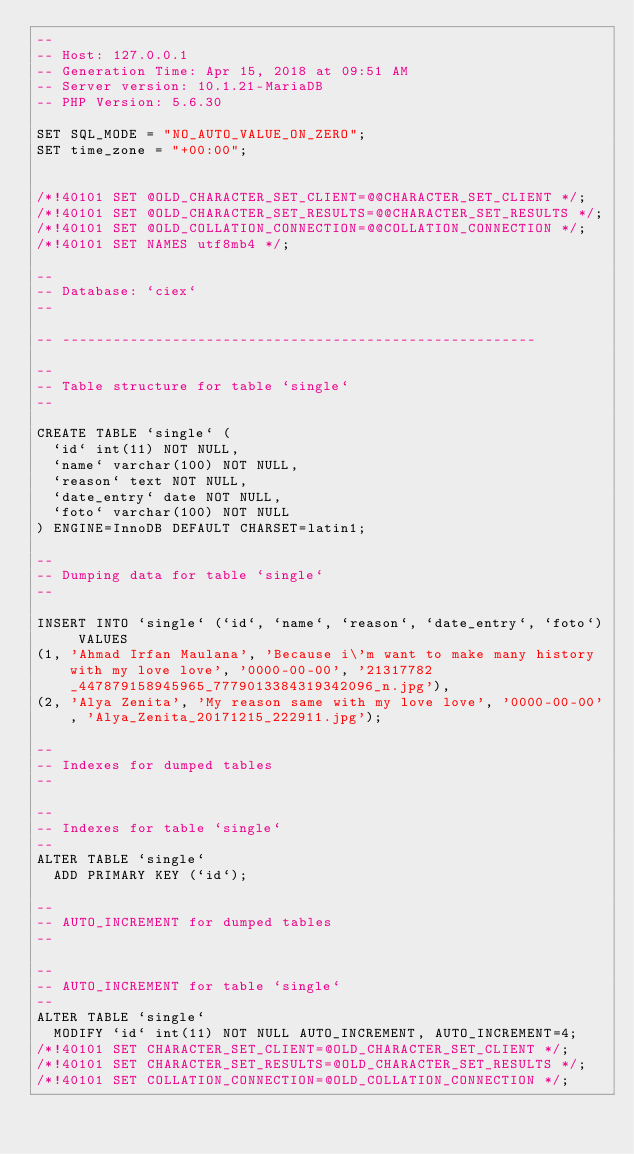Convert code to text. <code><loc_0><loc_0><loc_500><loc_500><_SQL_>--
-- Host: 127.0.0.1
-- Generation Time: Apr 15, 2018 at 09:51 AM
-- Server version: 10.1.21-MariaDB
-- PHP Version: 5.6.30

SET SQL_MODE = "NO_AUTO_VALUE_ON_ZERO";
SET time_zone = "+00:00";


/*!40101 SET @OLD_CHARACTER_SET_CLIENT=@@CHARACTER_SET_CLIENT */;
/*!40101 SET @OLD_CHARACTER_SET_RESULTS=@@CHARACTER_SET_RESULTS */;
/*!40101 SET @OLD_COLLATION_CONNECTION=@@COLLATION_CONNECTION */;
/*!40101 SET NAMES utf8mb4 */;

--
-- Database: `ciex`
--

-- --------------------------------------------------------

--
-- Table structure for table `single`
--

CREATE TABLE `single` (
  `id` int(11) NOT NULL,
  `name` varchar(100) NOT NULL,
  `reason` text NOT NULL,
  `date_entry` date NOT NULL,
  `foto` varchar(100) NOT NULL
) ENGINE=InnoDB DEFAULT CHARSET=latin1;

--
-- Dumping data for table `single`
--

INSERT INTO `single` (`id`, `name`, `reason`, `date_entry`, `foto`) VALUES
(1, 'Ahmad Irfan Maulana', 'Because i\'m want to make many history with my love love', '0000-00-00', '21317782_447879158945965_7779013384319342096_n.jpg'),
(2, 'Alya Zenita', 'My reason same with my love love', '0000-00-00', 'Alya_Zenita_20171215_222911.jpg');

--
-- Indexes for dumped tables
--

--
-- Indexes for table `single`
--
ALTER TABLE `single`
  ADD PRIMARY KEY (`id`);

--
-- AUTO_INCREMENT for dumped tables
--

--
-- AUTO_INCREMENT for table `single`
--
ALTER TABLE `single`
  MODIFY `id` int(11) NOT NULL AUTO_INCREMENT, AUTO_INCREMENT=4;
/*!40101 SET CHARACTER_SET_CLIENT=@OLD_CHARACTER_SET_CLIENT */;
/*!40101 SET CHARACTER_SET_RESULTS=@OLD_CHARACTER_SET_RESULTS */;
/*!40101 SET COLLATION_CONNECTION=@OLD_COLLATION_CONNECTION */;
</code> 